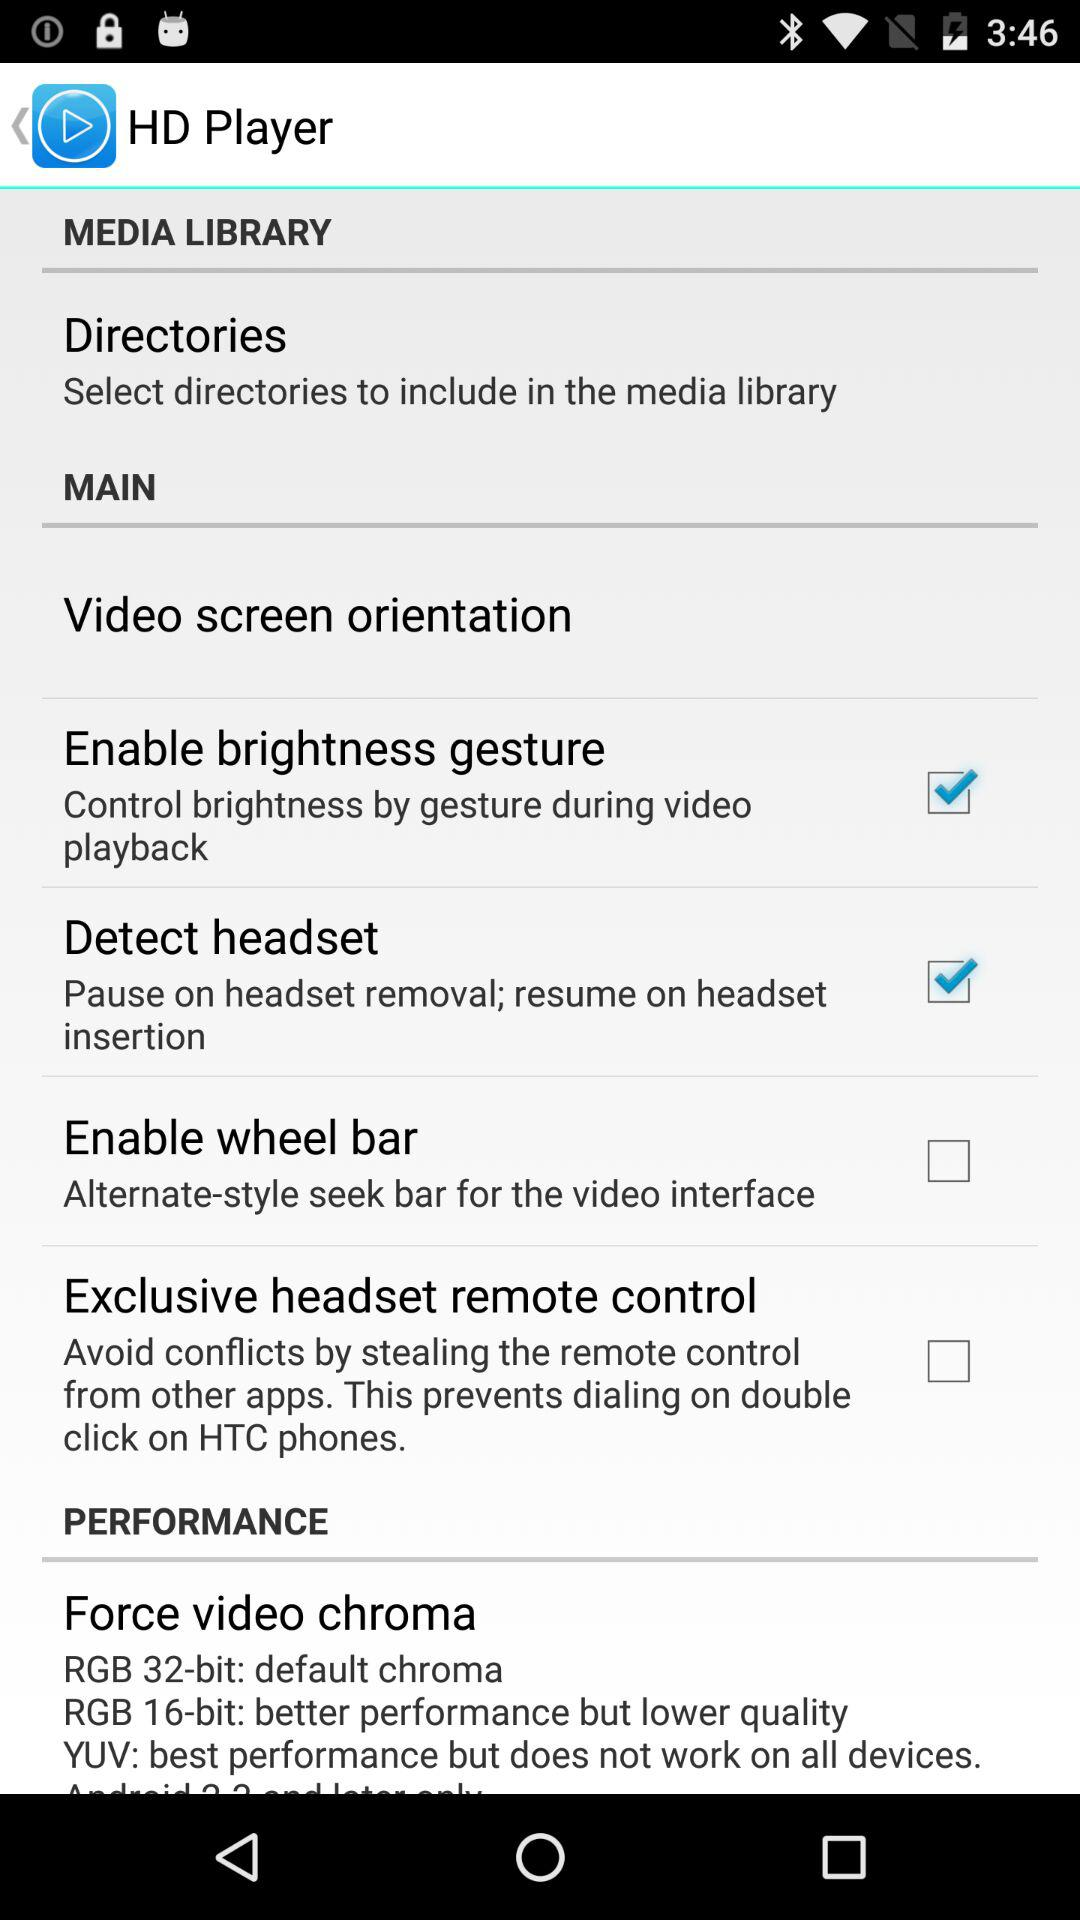What is the status of the "Enable wheel bar"? The status is "off". 